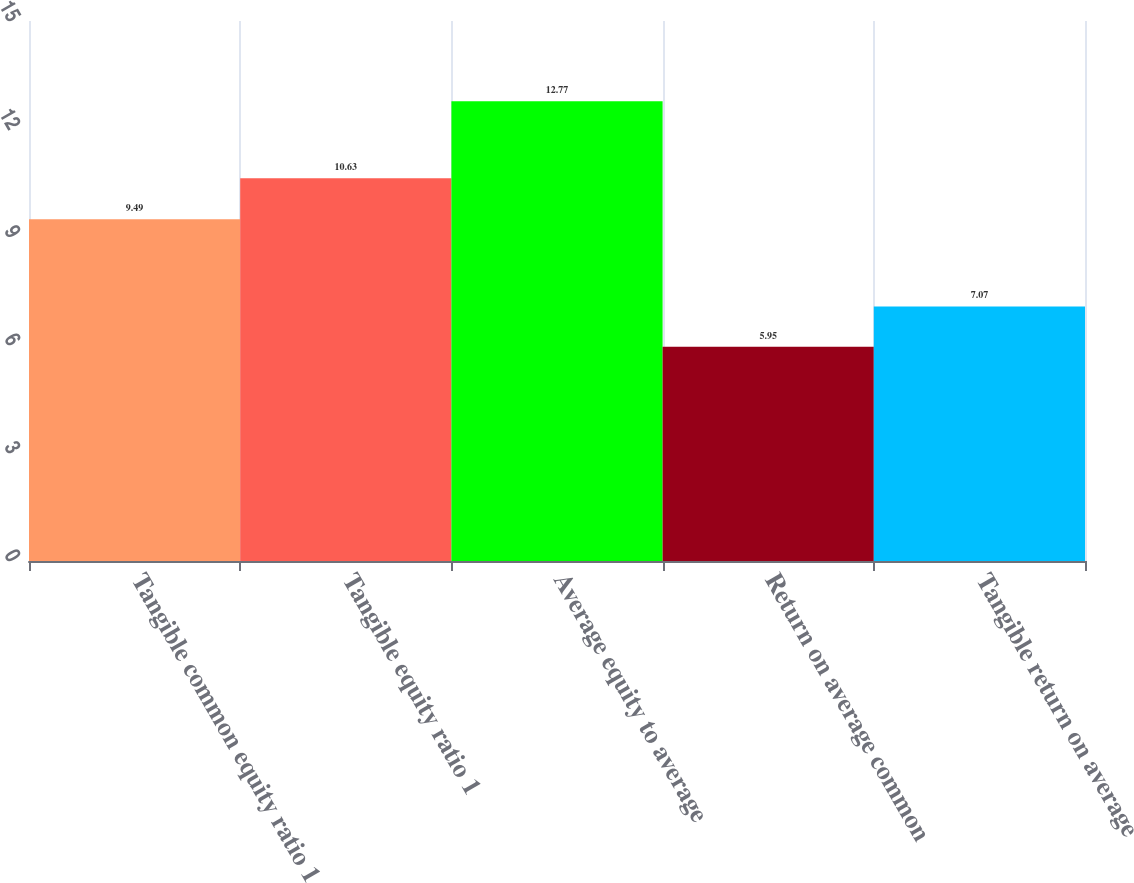Convert chart. <chart><loc_0><loc_0><loc_500><loc_500><bar_chart><fcel>Tangible common equity ratio 1<fcel>Tangible equity ratio 1<fcel>Average equity to average<fcel>Return on average common<fcel>Tangible return on average<nl><fcel>9.49<fcel>10.63<fcel>12.77<fcel>5.95<fcel>7.07<nl></chart> 